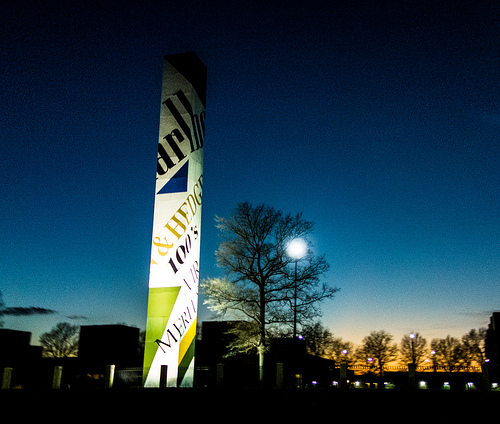<image>
Is there a lighted sign to the left of the tree? Yes. From this viewpoint, the lighted sign is positioned to the left side relative to the tree. 